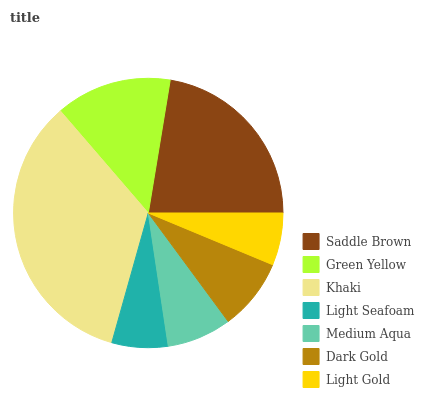Is Light Gold the minimum?
Answer yes or no. Yes. Is Khaki the maximum?
Answer yes or no. Yes. Is Green Yellow the minimum?
Answer yes or no. No. Is Green Yellow the maximum?
Answer yes or no. No. Is Saddle Brown greater than Green Yellow?
Answer yes or no. Yes. Is Green Yellow less than Saddle Brown?
Answer yes or no. Yes. Is Green Yellow greater than Saddle Brown?
Answer yes or no. No. Is Saddle Brown less than Green Yellow?
Answer yes or no. No. Is Dark Gold the high median?
Answer yes or no. Yes. Is Dark Gold the low median?
Answer yes or no. Yes. Is Light Seafoam the high median?
Answer yes or no. No. Is Green Yellow the low median?
Answer yes or no. No. 